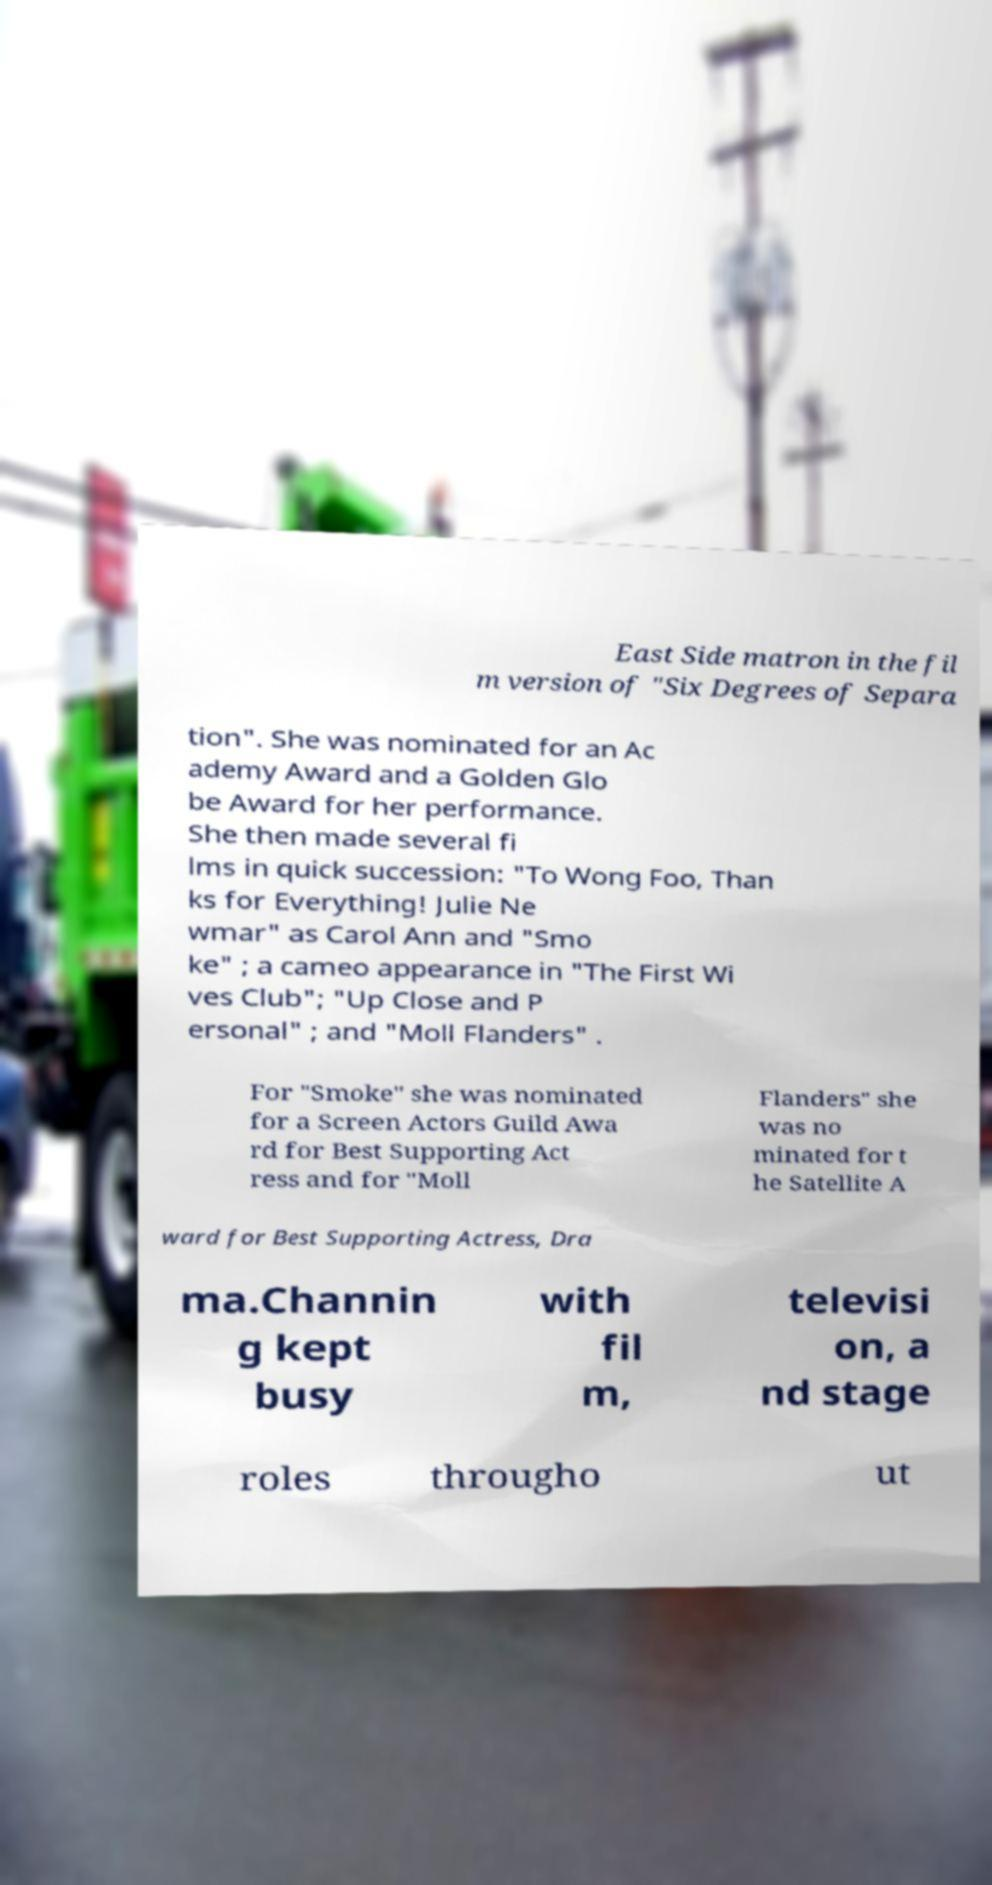Could you extract and type out the text from this image? East Side matron in the fil m version of "Six Degrees of Separa tion". She was nominated for an Ac ademy Award and a Golden Glo be Award for her performance. She then made several fi lms in quick succession: "To Wong Foo, Than ks for Everything! Julie Ne wmar" as Carol Ann and "Smo ke" ; a cameo appearance in "The First Wi ves Club"; "Up Close and P ersonal" ; and "Moll Flanders" . For "Smoke" she was nominated for a Screen Actors Guild Awa rd for Best Supporting Act ress and for "Moll Flanders" she was no minated for t he Satellite A ward for Best Supporting Actress, Dra ma.Channin g kept busy with fil m, televisi on, a nd stage roles througho ut 